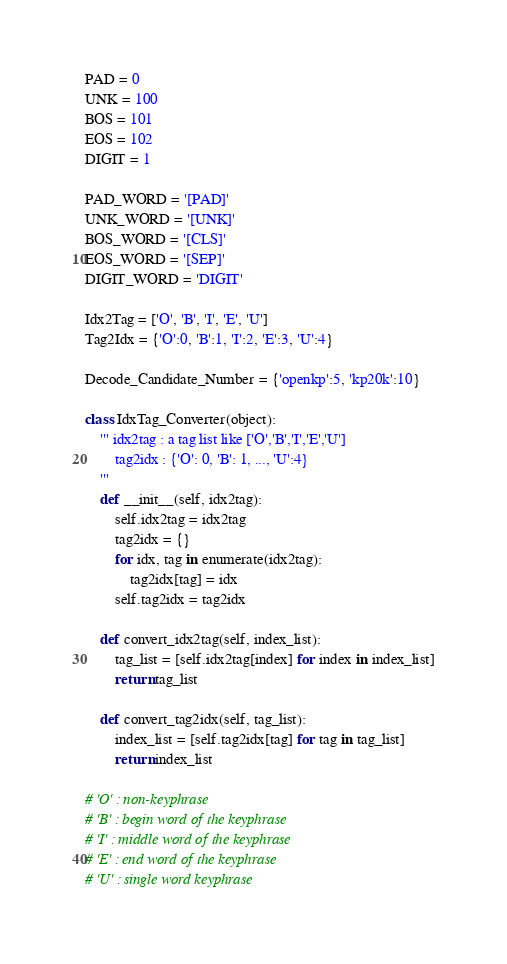Convert code to text. <code><loc_0><loc_0><loc_500><loc_500><_Python_>PAD = 0
UNK = 100
BOS = 101
EOS = 102
DIGIT = 1

PAD_WORD = '[PAD]'
UNK_WORD = '[UNK]'
BOS_WORD = '[CLS]'
EOS_WORD = '[SEP]'
DIGIT_WORD = 'DIGIT'

Idx2Tag = ['O', 'B', 'I', 'E', 'U']
Tag2Idx = {'O':0, 'B':1, 'I':2, 'E':3, 'U':4}

Decode_Candidate_Number = {'openkp':5, 'kp20k':10}

class IdxTag_Converter(object):
    ''' idx2tag : a tag list like ['O','B','I','E','U']
        tag2idx : {'O': 0, 'B': 1, ..., 'U':4}
    '''
    def __init__(self, idx2tag):
        self.idx2tag = idx2tag
        tag2idx = {}
        for idx, tag in enumerate(idx2tag):
            tag2idx[tag] = idx
        self.tag2idx = tag2idx
        
    def convert_idx2tag(self, index_list):
        tag_list = [self.idx2tag[index] for index in index_list]
        return tag_list
        
    def convert_tag2idx(self, tag_list):
        index_list = [self.tag2idx[tag] for tag in tag_list]
        return index_list

# 'O' : non-keyphrase
# 'B' : begin word of the keyphrase
# 'I' : middle word of the keyphrase
# 'E' : end word of the keyphrase
# 'U' : single word keyphrase</code> 